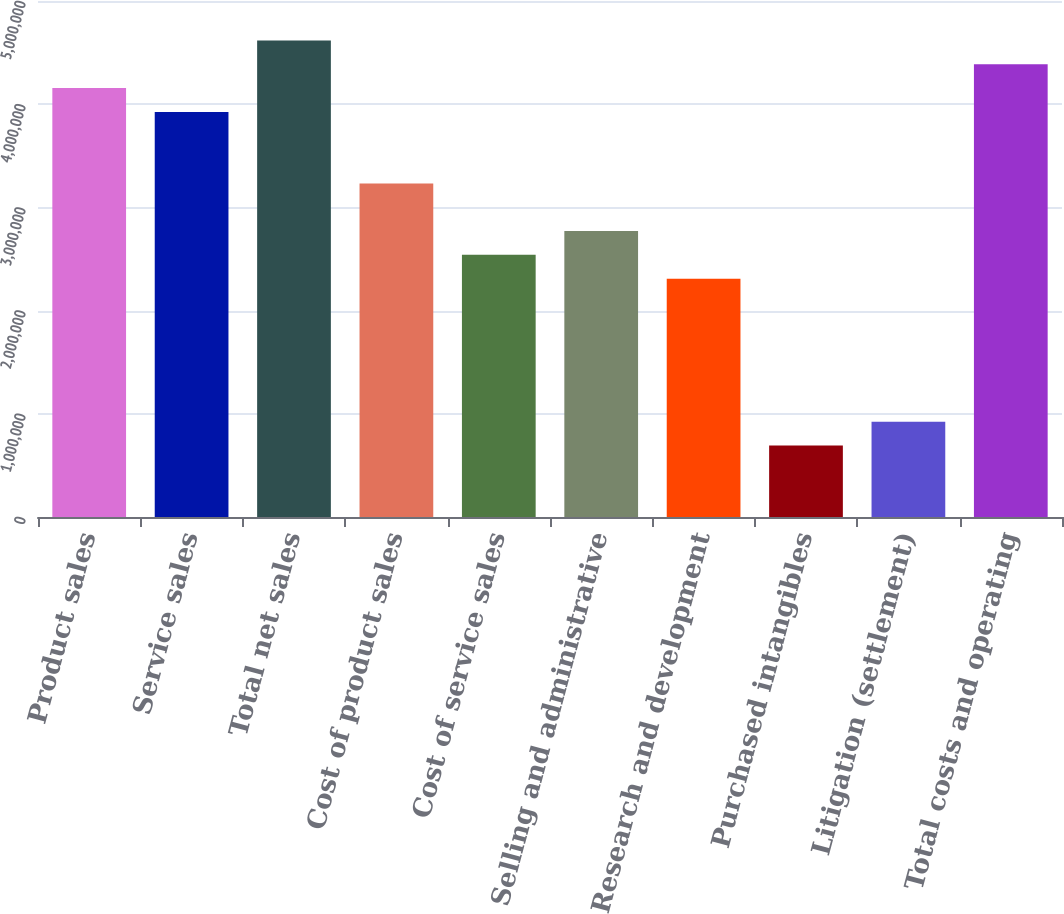Convert chart. <chart><loc_0><loc_0><loc_500><loc_500><bar_chart><fcel>Product sales<fcel>Service sales<fcel>Total net sales<fcel>Cost of product sales<fcel>Cost of service sales<fcel>Selling and administrative<fcel>Research and development<fcel>Purchased intangibles<fcel>Litigation (settlement)<fcel>Total costs and operating<nl><fcel>4.15634e+06<fcel>3.92543e+06<fcel>4.61816e+06<fcel>3.23271e+06<fcel>2.53999e+06<fcel>2.77089e+06<fcel>2.30908e+06<fcel>692724<fcel>923631<fcel>4.38725e+06<nl></chart> 